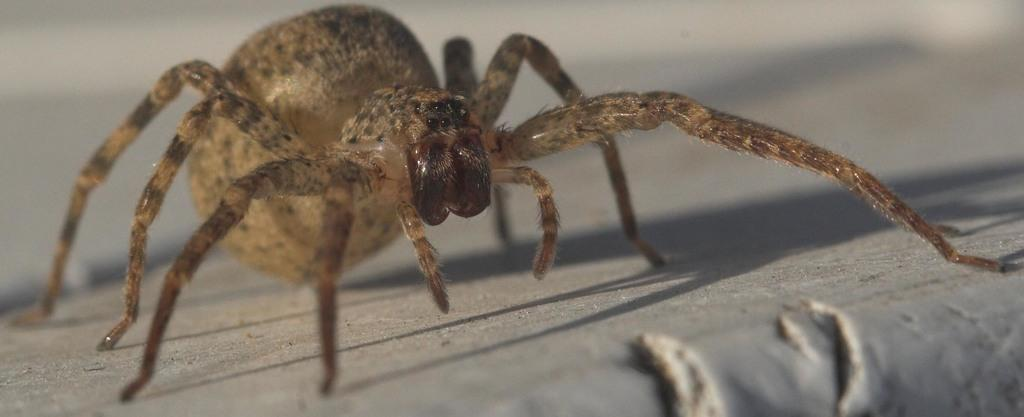What is the main subject of the image? The main subject of the image is a spider. Where is the spider located in the image? The spider is on the ground in the image. What type of market is the spider attending in the image? There is no market present in the image, and the spider is not attending any event. 